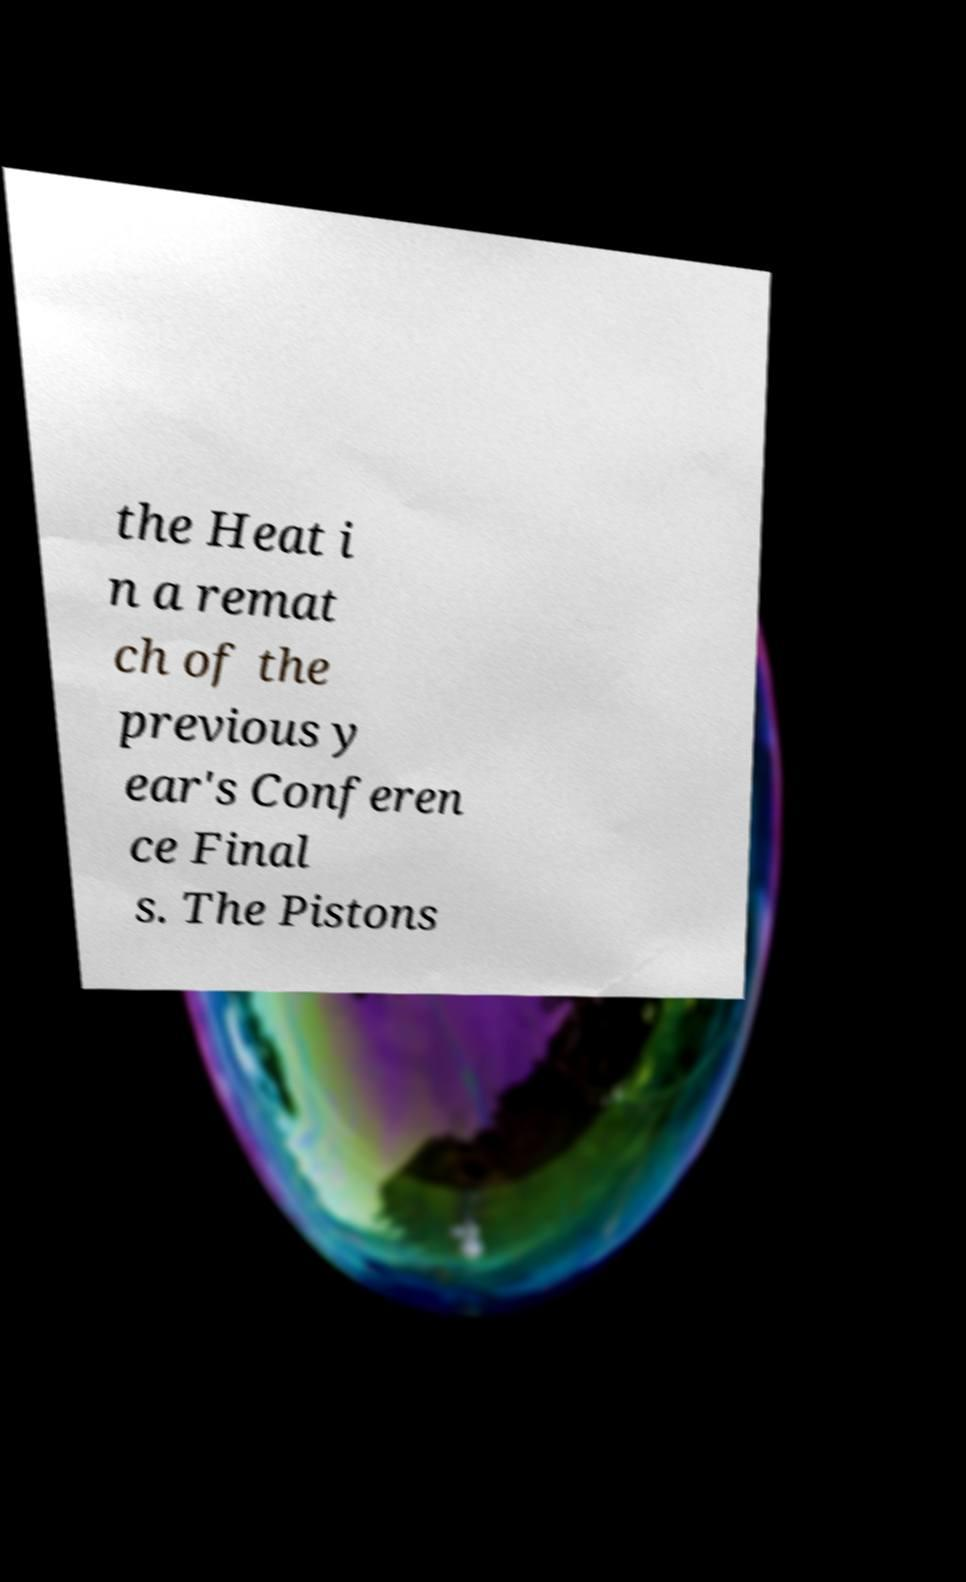Could you extract and type out the text from this image? the Heat i n a remat ch of the previous y ear's Conferen ce Final s. The Pistons 